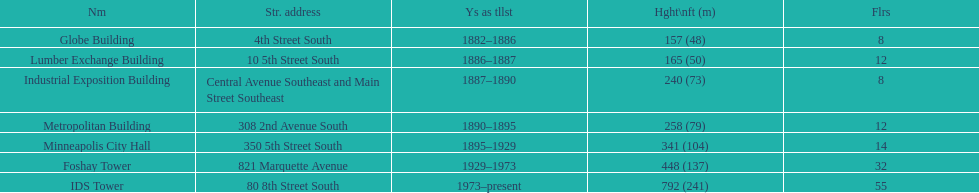Which was the foremost edifice identified as the tallest? Globe Building. 